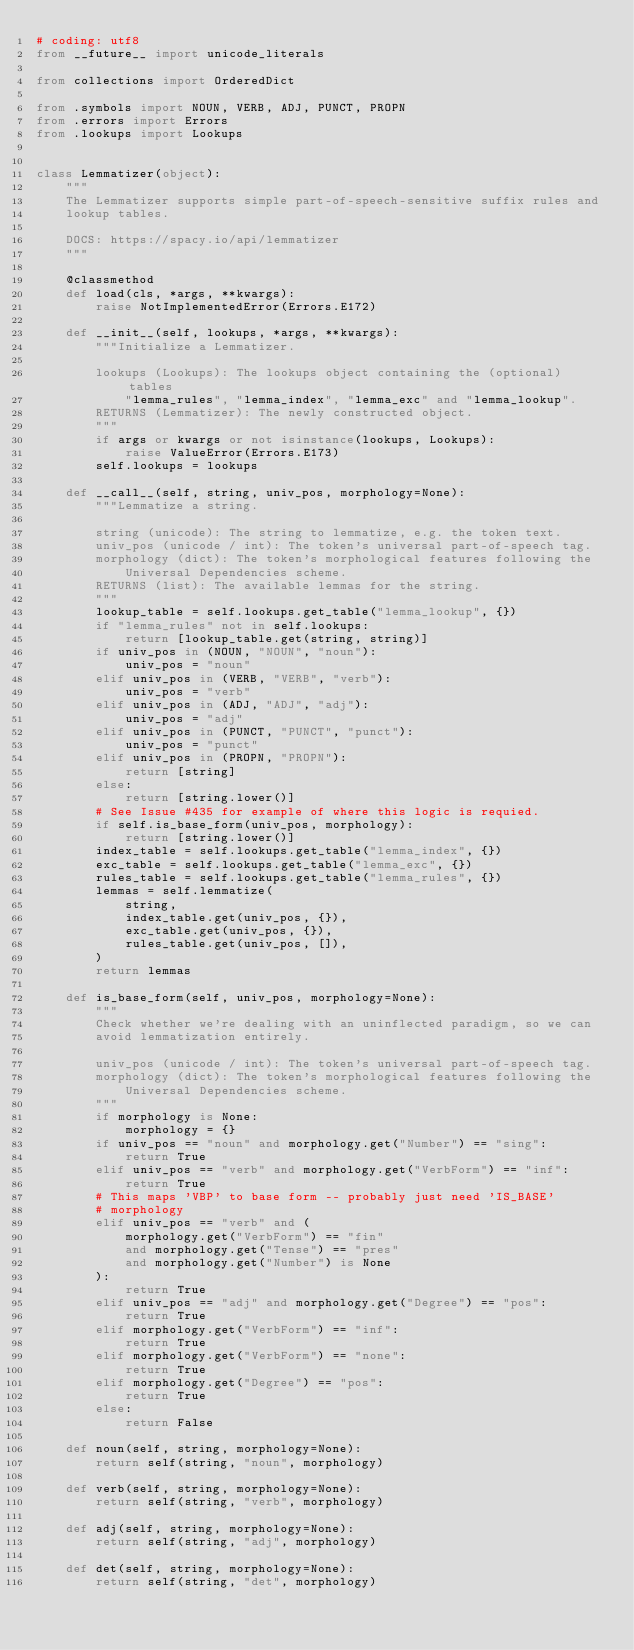<code> <loc_0><loc_0><loc_500><loc_500><_Python_># coding: utf8
from __future__ import unicode_literals

from collections import OrderedDict

from .symbols import NOUN, VERB, ADJ, PUNCT, PROPN
from .errors import Errors
from .lookups import Lookups


class Lemmatizer(object):
    """
    The Lemmatizer supports simple part-of-speech-sensitive suffix rules and
    lookup tables.

    DOCS: https://spacy.io/api/lemmatizer
    """

    @classmethod
    def load(cls, *args, **kwargs):
        raise NotImplementedError(Errors.E172)

    def __init__(self, lookups, *args, **kwargs):
        """Initialize a Lemmatizer.

        lookups (Lookups): The lookups object containing the (optional) tables
            "lemma_rules", "lemma_index", "lemma_exc" and "lemma_lookup".
        RETURNS (Lemmatizer): The newly constructed object.
        """
        if args or kwargs or not isinstance(lookups, Lookups):
            raise ValueError(Errors.E173)
        self.lookups = lookups

    def __call__(self, string, univ_pos, morphology=None):
        """Lemmatize a string.

        string (unicode): The string to lemmatize, e.g. the token text.
        univ_pos (unicode / int): The token's universal part-of-speech tag.
        morphology (dict): The token's morphological features following the
            Universal Dependencies scheme.
        RETURNS (list): The available lemmas for the string.
        """
        lookup_table = self.lookups.get_table("lemma_lookup", {})
        if "lemma_rules" not in self.lookups:
            return [lookup_table.get(string, string)]
        if univ_pos in (NOUN, "NOUN", "noun"):
            univ_pos = "noun"
        elif univ_pos in (VERB, "VERB", "verb"):
            univ_pos = "verb"
        elif univ_pos in (ADJ, "ADJ", "adj"):
            univ_pos = "adj"
        elif univ_pos in (PUNCT, "PUNCT", "punct"):
            univ_pos = "punct"
        elif univ_pos in (PROPN, "PROPN"):
            return [string]
        else:
            return [string.lower()]
        # See Issue #435 for example of where this logic is requied.
        if self.is_base_form(univ_pos, morphology):
            return [string.lower()]
        index_table = self.lookups.get_table("lemma_index", {})
        exc_table = self.lookups.get_table("lemma_exc", {})
        rules_table = self.lookups.get_table("lemma_rules", {})
        lemmas = self.lemmatize(
            string,
            index_table.get(univ_pos, {}),
            exc_table.get(univ_pos, {}),
            rules_table.get(univ_pos, []),
        )
        return lemmas

    def is_base_form(self, univ_pos, morphology=None):
        """
        Check whether we're dealing with an uninflected paradigm, so we can
        avoid lemmatization entirely.

        univ_pos (unicode / int): The token's universal part-of-speech tag.
        morphology (dict): The token's morphological features following the
            Universal Dependencies scheme.
        """
        if morphology is None:
            morphology = {}
        if univ_pos == "noun" and morphology.get("Number") == "sing":
            return True
        elif univ_pos == "verb" and morphology.get("VerbForm") == "inf":
            return True
        # This maps 'VBP' to base form -- probably just need 'IS_BASE'
        # morphology
        elif univ_pos == "verb" and (
            morphology.get("VerbForm") == "fin"
            and morphology.get("Tense") == "pres"
            and morphology.get("Number") is None
        ):
            return True
        elif univ_pos == "adj" and morphology.get("Degree") == "pos":
            return True
        elif morphology.get("VerbForm") == "inf":
            return True
        elif morphology.get("VerbForm") == "none":
            return True
        elif morphology.get("Degree") == "pos":
            return True
        else:
            return False

    def noun(self, string, morphology=None):
        return self(string, "noun", morphology)

    def verb(self, string, morphology=None):
        return self(string, "verb", morphology)

    def adj(self, string, morphology=None):
        return self(string, "adj", morphology)

    def det(self, string, morphology=None):
        return self(string, "det", morphology)
</code> 